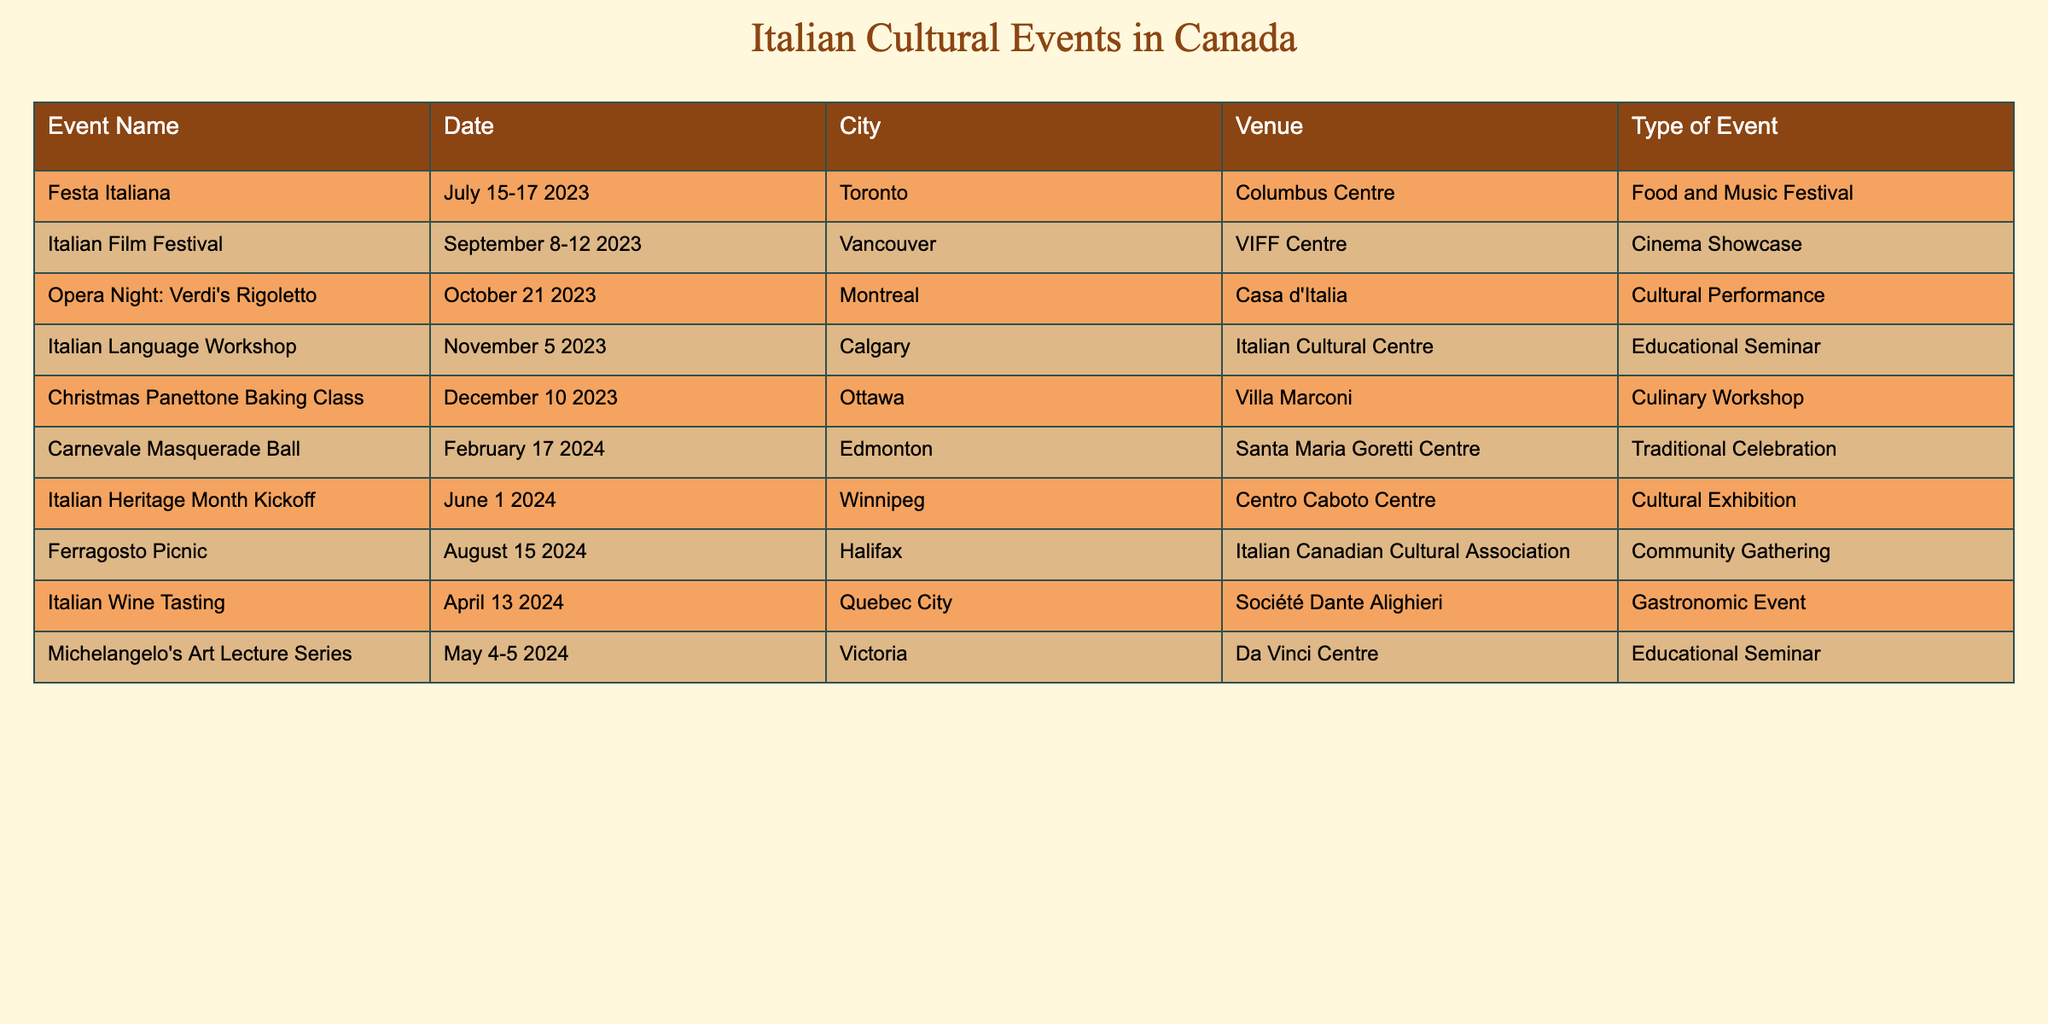What is the date of the Italian Film Festival? The table lists the date for the Italian Film Festival under the "Date" column. It is shown as September 8-12 2023.
Answer: September 8-12 2023 Which city will host the Christmas Panettone Baking Class? The "City" column shows the associated city for the event "Christmas Panettone Baking Class," which is Ottawa.
Answer: Ottawa How many events are scheduled in the city of Montreal? By counting the number of events listed in the "City" column for Montreal, there is 1 event, which is "Opera Night: Verdi's Rigoletto."
Answer: 1 Are there any culinary workshops scheduled in 2024? Looking at the "Type of Event" column, we see the event "Italian Wine Tasting" in April 2024, which is a gastronomic event. This does not classify as a culinary workshop, while the "Christmas Panettone Baking Class" in December 2023 is indeed a culinary workshop. Thus the answer is no.
Answer: No What is the total number of events scheduled in the spring months (March, April, and May) of 2024? The events during the spring months are "Italian Wine Tasting" in April and "Michelangelo's Art Lecture Series" in May. So, we have a total of 2 events.
Answer: 2 When is the Carnevale Masquerade Ball scheduled? The "Date" column contains the date for the "Carnevale Masquerade Ball," which is listed as February 17 2024.
Answer: February 17 2024 Is there an event focused on the Italian language? Yes, based on the "Type of Event" column, "Italian Language Workshop" is an educational seminar focused on the Italian language scheduled for November 5 2023 in Calgary.
Answer: Yes Which city has the most cultural events scheduled from now until June 2024? Counting the events listed for each city, Toronto has 1, Vancouver has 1, Montreal has 1, Calgary has 1, Ottawa has 1, Edmonton has 1, Winnipeg has 1, Halifax has 1, and Quebec City has 1, and Victoria also has 1 event. Each city has an equal number; thus, no city has more events.
Answer: No city has more events 